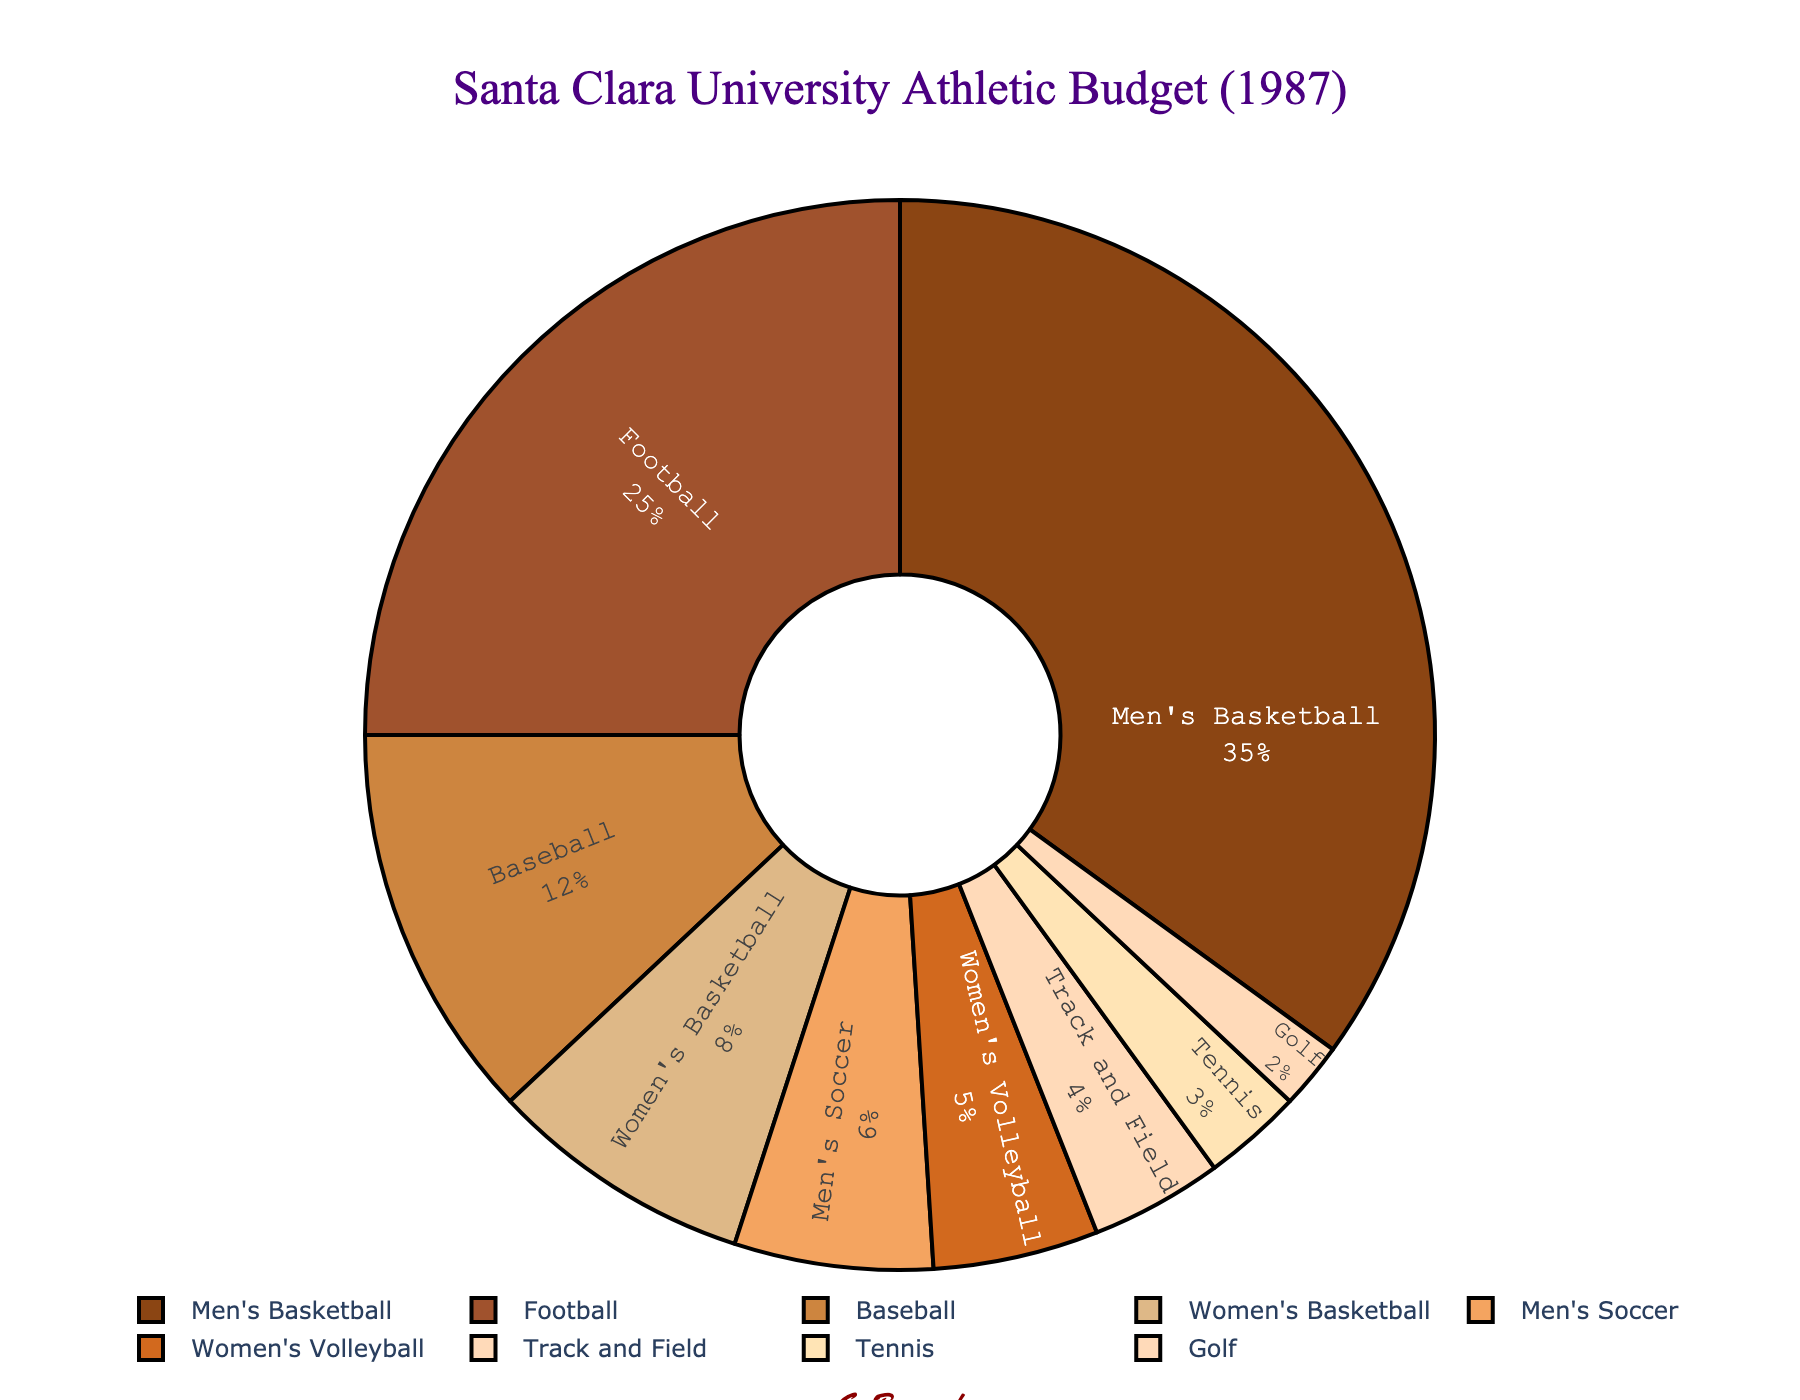What are the three sports with the highest percentage of the athletic budget? Look at the pie chart. The largest segments, labeled inside with percentages, represent Men's Basketball (35%), Football (25%), and Baseball (12%).
Answer: Men's Basketball, Football, Baseball What is the combined budget percentage for Men's Soccer and Women's Volleyball? Add the percentages of Men's Soccer (6%) and Women's Volleyball (5%). 6 + 5 = 11.
Answer: 11% Which sport has the smallest percentage of the athletic budget? Identify the smallest segment in the pie chart, which is labeled with its percentage. It's Golf with 2%.
Answer: Golf How much more budget percentage does Men's Basketball receive compared to Women's Basketball? Subtract the percentage of Women's Basketball (8%) from Men's Basketball (35%). 35 - 8 = 27.
Answer: 27% Is the budget percentage for Baseball larger or smaller than the combined budget percentage for Track and Field, Tennis, and Golf? Add the percentages for Track and Field (4%), Tennis (3%), and Golf (2%). 4 + 3 + 2 = 9%, which is less than Baseball's 12%.
Answer: Larger What is the budget percentage for sports other than Men's Basketball and Football? Subtract the total percentage of Men's Basketball (35%) and Football (25%) from 100%. 100 - 35 - 25 = 40%.
Answer: 40% What percentage of the budget is allocated to women’s sports? Add the percentages for Women's Basketball (8%) and Women's Volleyball (5%). 8 + 5 = 13%.
Answer: 13% Rank the sports in descending order based on their budget percentages. Order the percentages from largest to smallest: Men's Basketball (35%), Football (25%), Baseball (12%), Women's Basketball (8%), Men's Soccer (6%), Women's Volleyball (5%), Track and Field (4%), Tennis (3%), Golf (2%).
Answer: Men's Basketball, Football, Baseball, Women's Basketball, Men's Soccer, Women's Volleyball, Track and Field, Tennis, Golf If you were to increase the Women's Basketball budget by 5%, what would be the new total percentage for Women's Basketball? Add 5% to the existing Women's Basketball percentage (8%). 8 + 5 = 13%.
Answer: 13% How does the budget for Men's Soccer compare with Women's Volleyball? Compare the percentages directly: Men's Soccer has 6% and Women's Volleyball has 5%, so Men's Soccer has a 1% higher budget.
Answer: Men's Soccer has a higher budget 